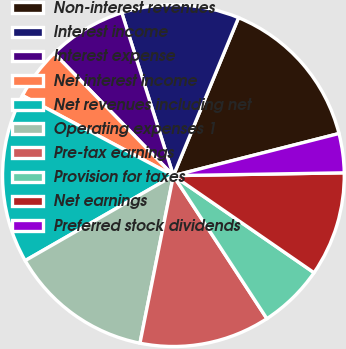Convert chart to OTSL. <chart><loc_0><loc_0><loc_500><loc_500><pie_chart><fcel>Non-interest revenues<fcel>Interest income<fcel>Interest expense<fcel>Net interest income<fcel>Net revenues including net<fcel>Operating expenses 1<fcel>Pre-tax earnings<fcel>Provision for taxes<fcel>Net earnings<fcel>Preferred stock dividends<nl><fcel>14.81%<fcel>11.11%<fcel>7.41%<fcel>4.94%<fcel>16.05%<fcel>13.58%<fcel>12.35%<fcel>6.17%<fcel>9.88%<fcel>3.7%<nl></chart> 